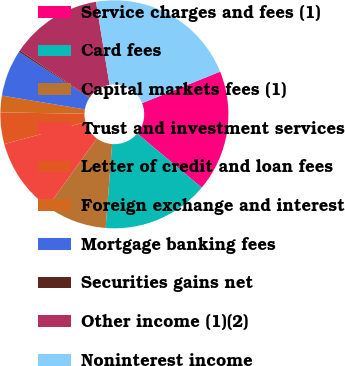Convert chart. <chart><loc_0><loc_0><loc_500><loc_500><pie_chart><fcel>Service charges and fees (1)<fcel>Card fees<fcel>Capital markets fees (1)<fcel>Trust and investment services<fcel>Letter of credit and loan fees<fcel>Foreign exchange and interest<fcel>Mortgage banking fees<fcel>Securities gains net<fcel>Other income (1)(2)<fcel>Noninterest income<nl><fcel>17.22%<fcel>15.1%<fcel>8.73%<fcel>10.85%<fcel>4.48%<fcel>2.35%<fcel>6.6%<fcel>0.23%<fcel>12.97%<fcel>21.47%<nl></chart> 